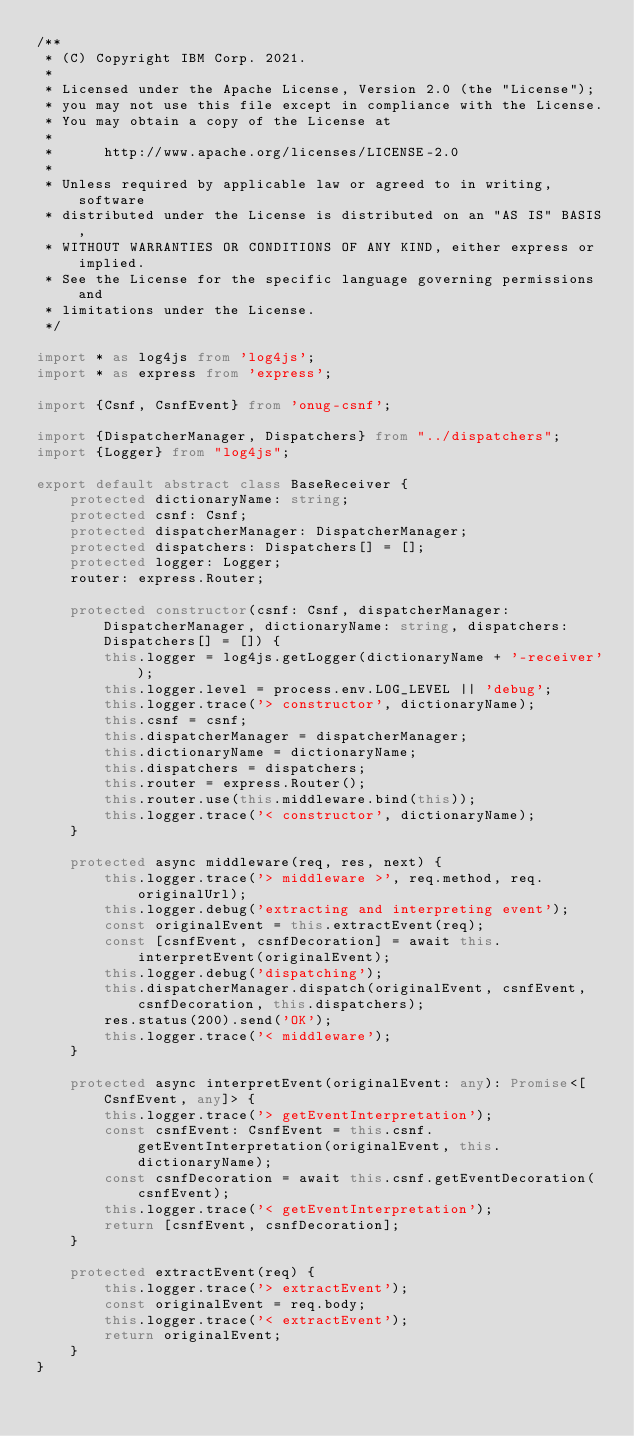<code> <loc_0><loc_0><loc_500><loc_500><_TypeScript_>/**
 * (C) Copyright IBM Corp. 2021.
 *
 * Licensed under the Apache License, Version 2.0 (the "License");
 * you may not use this file except in compliance with the License.
 * You may obtain a copy of the License at
 *
 *      http://www.apache.org/licenses/LICENSE-2.0
 *
 * Unless required by applicable law or agreed to in writing, software
 * distributed under the License is distributed on an "AS IS" BASIS,
 * WITHOUT WARRANTIES OR CONDITIONS OF ANY KIND, either express or implied.
 * See the License for the specific language governing permissions and
 * limitations under the License.
 */

import * as log4js from 'log4js';
import * as express from 'express';

import {Csnf, CsnfEvent} from 'onug-csnf';

import {DispatcherManager, Dispatchers} from "../dispatchers";
import {Logger} from "log4js";

export default abstract class BaseReceiver {
    protected dictionaryName: string;
    protected csnf: Csnf;
    protected dispatcherManager: DispatcherManager;
    protected dispatchers: Dispatchers[] = [];
    protected logger: Logger;
    router: express.Router;

    protected constructor(csnf: Csnf, dispatcherManager: DispatcherManager, dictionaryName: string, dispatchers: Dispatchers[] = []) {
        this.logger = log4js.getLogger(dictionaryName + '-receiver');
        this.logger.level = process.env.LOG_LEVEL || 'debug';
        this.logger.trace('> constructor', dictionaryName);
        this.csnf = csnf;
        this.dispatcherManager = dispatcherManager;
        this.dictionaryName = dictionaryName;
        this.dispatchers = dispatchers;
        this.router = express.Router();
        this.router.use(this.middleware.bind(this));
        this.logger.trace('< constructor', dictionaryName);
    }

    protected async middleware(req, res, next) {
        this.logger.trace('> middleware >', req.method, req.originalUrl);
        this.logger.debug('extracting and interpreting event');
        const originalEvent = this.extractEvent(req);
        const [csnfEvent, csnfDecoration] = await this.interpretEvent(originalEvent);
        this.logger.debug('dispatching');
        this.dispatcherManager.dispatch(originalEvent, csnfEvent, csnfDecoration, this.dispatchers);
        res.status(200).send('OK');
        this.logger.trace('< middleware');
    }

    protected async interpretEvent(originalEvent: any): Promise<[CsnfEvent, any]> {
        this.logger.trace('> getEventInterpretation');
        const csnfEvent: CsnfEvent = this.csnf.getEventInterpretation(originalEvent, this.dictionaryName);
        const csnfDecoration = await this.csnf.getEventDecoration(csnfEvent);
        this.logger.trace('< getEventInterpretation');
        return [csnfEvent, csnfDecoration];
    }

    protected extractEvent(req) {
        this.logger.trace('> extractEvent');
        const originalEvent = req.body;
        this.logger.trace('< extractEvent');
        return originalEvent;
    }
}</code> 